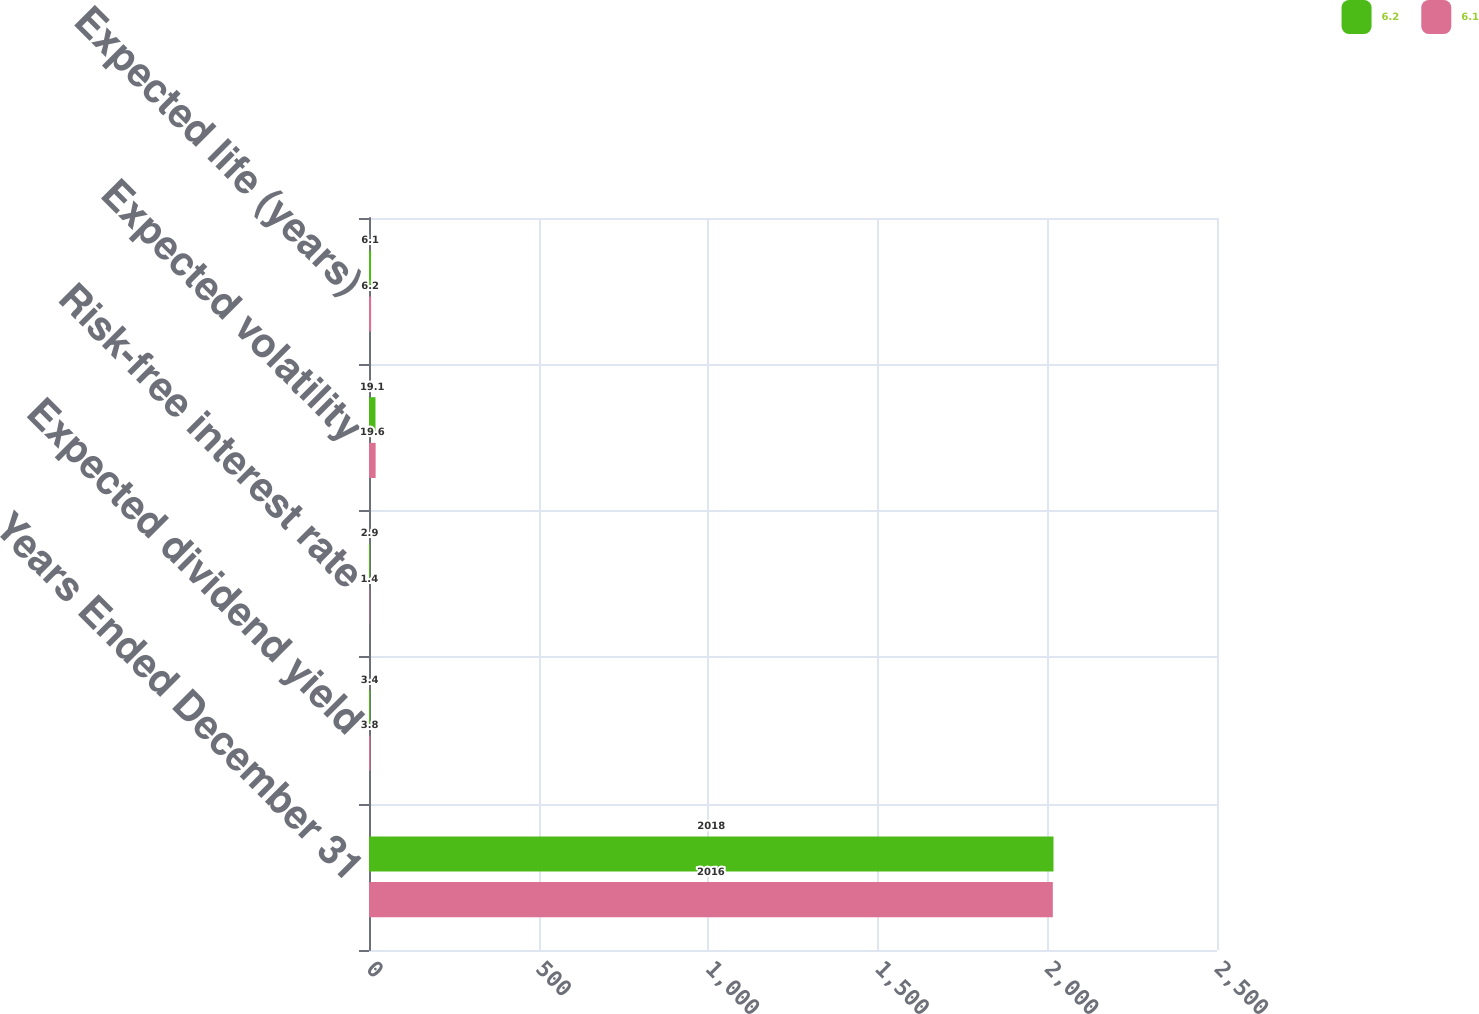Convert chart to OTSL. <chart><loc_0><loc_0><loc_500><loc_500><stacked_bar_chart><ecel><fcel>Years Ended December 31<fcel>Expected dividend yield<fcel>Risk-free interest rate<fcel>Expected volatility<fcel>Expected life (years)<nl><fcel>6.2<fcel>2018<fcel>3.4<fcel>2.9<fcel>19.1<fcel>6.1<nl><fcel>6.1<fcel>2016<fcel>3.8<fcel>1.4<fcel>19.6<fcel>6.2<nl></chart> 